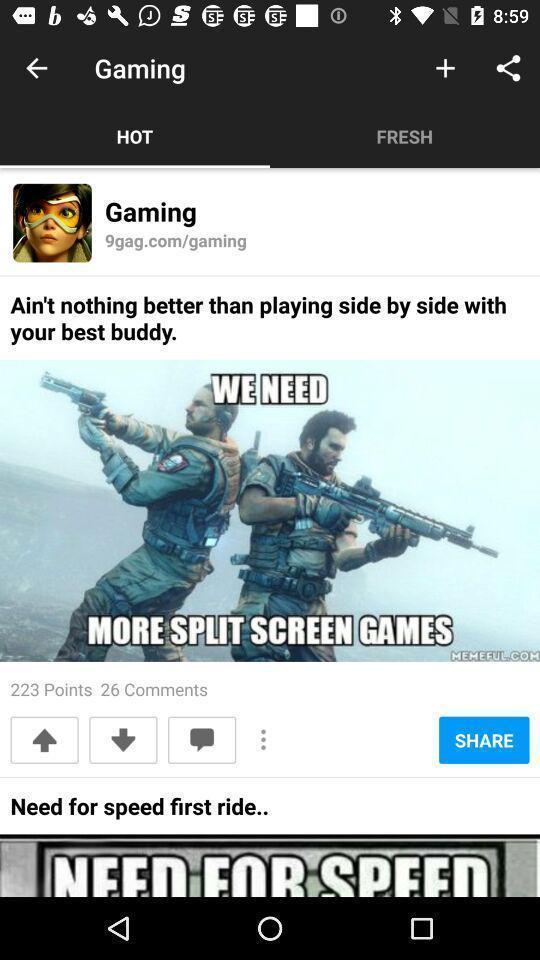What is the overall content of this screenshot? Page showing the games. 